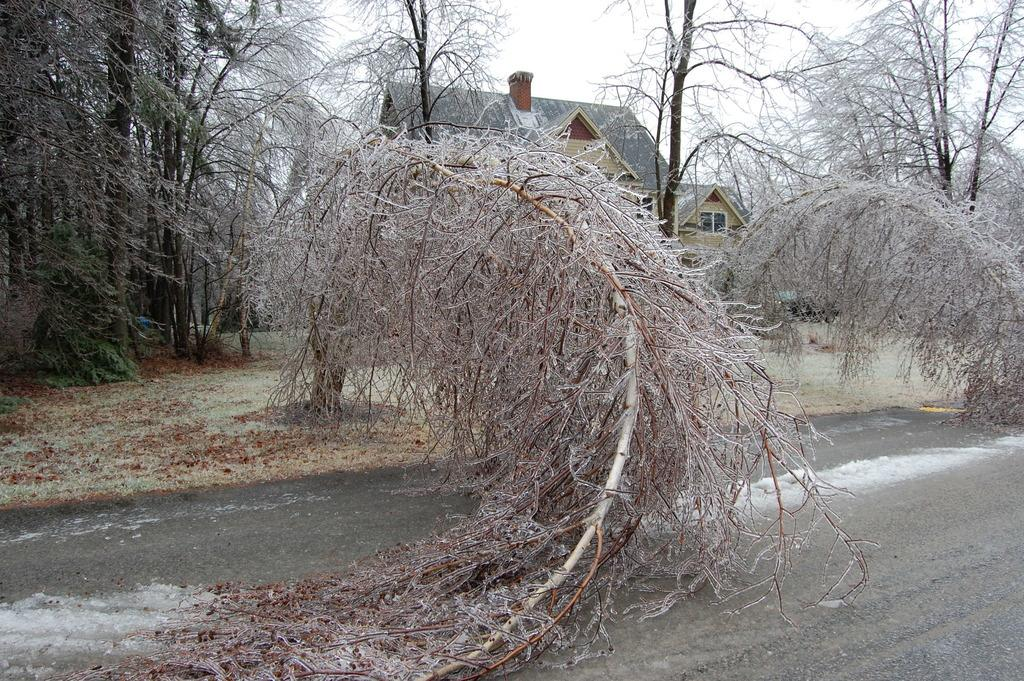What is at the bottom of the image? There is a road at the bottom of the image. What is the condition of the road? There is snow on the road. What can be seen in the background of the image? There are trees and a house visible in the background of the image. How are the trees in the background of the image? The trees are covered in snow. What color is the eye of the person walking on the snowy road in the image? There is no person walking on the snowy road in the image, and therefore no eye to observe. 